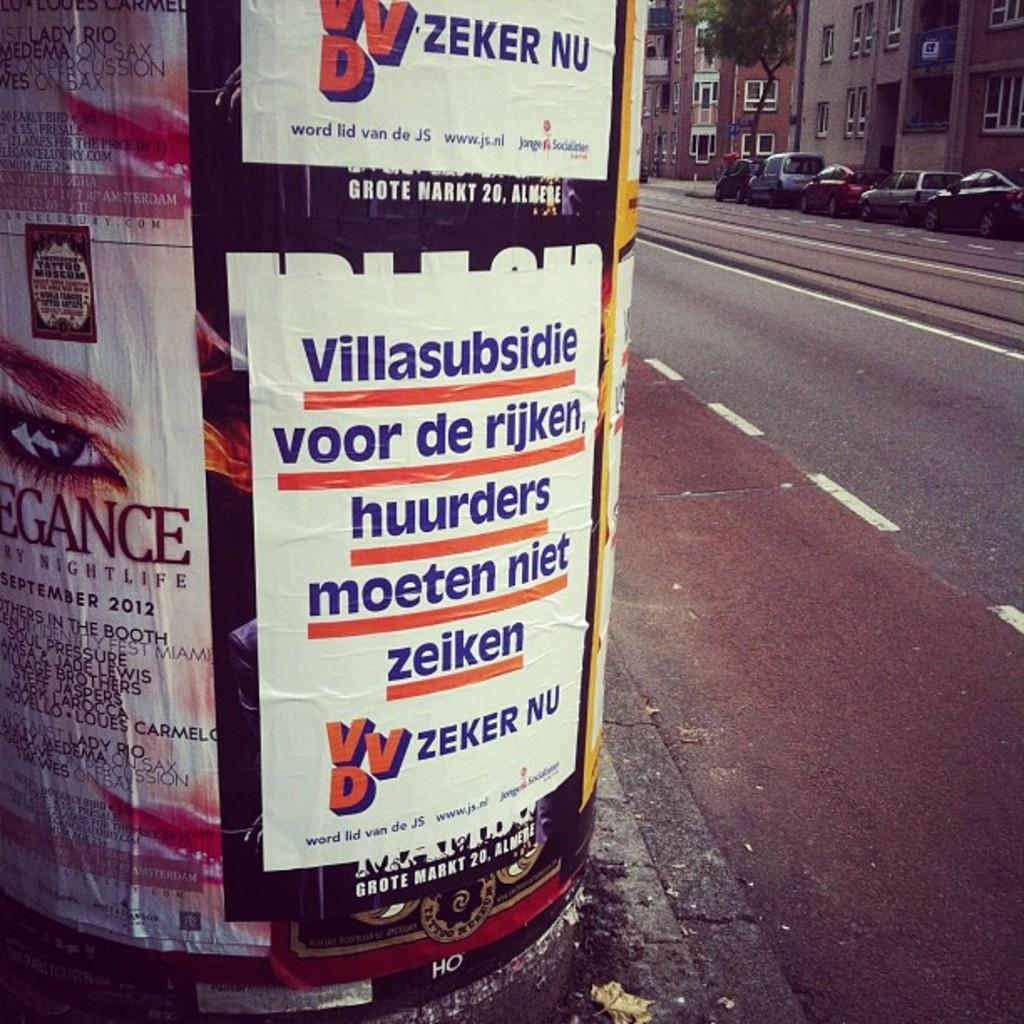<image>
Create a compact narrative representing the image presented. the letters VVD are on the bottom of a white sign 